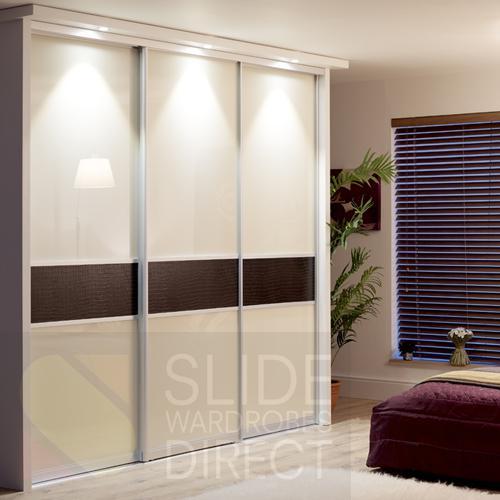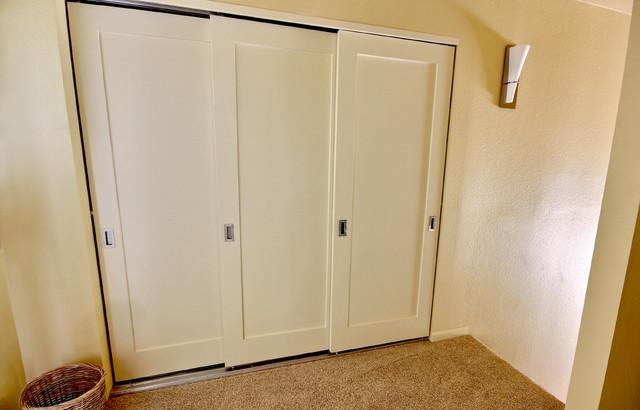The first image is the image on the left, the second image is the image on the right. For the images shown, is this caption "An image shows a three-section white sliding door unit with round dark handles." true? Answer yes or no. No. The first image is the image on the left, the second image is the image on the right. Considering the images on both sides, is "One three panel door has visible hardware on each door and a second three panel door has a contrasting middle band and no visible hardware." valid? Answer yes or no. Yes. 